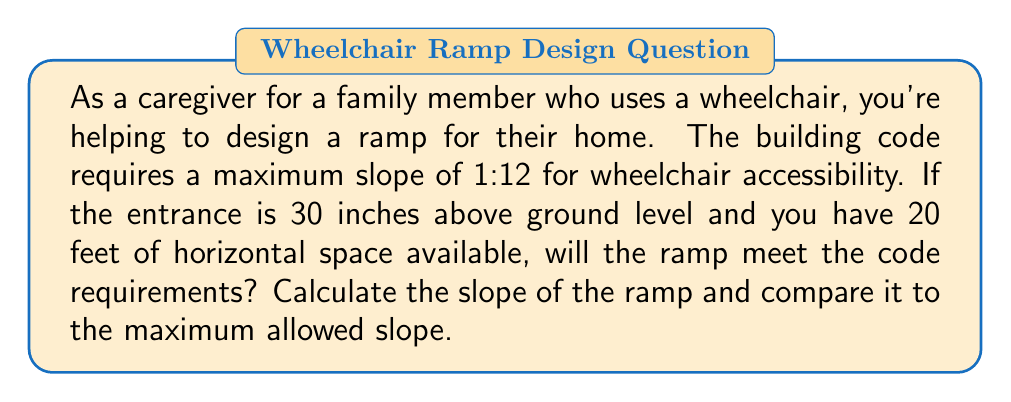Could you help me with this problem? Let's approach this step-by-step:

1) First, let's recall the formula for slope:

   $$ \text{Slope} = \frac{\text{Rise}}{\text{Run}} $$

2) In this case:
   - Rise = 30 inches (vertical distance)
   - Run = 20 feet = 240 inches (horizontal distance)

3) Calculate the slope:

   $$ \text{Slope} = \frac{30 \text{ inches}}{240 \text{ inches}} = \frac{1}{8} = 0.125 $$

4) To compare with the code requirement, let's convert 1:12 to a decimal:

   $$ \frac{1}{12} \approx 0.0833 $$

5) Compare the calculated slope to the maximum allowed slope:

   $0.125 > 0.0833$

6) The calculated slope (1:8) is steeper than the maximum allowed slope (1:12).

[asy]
unitsize(1cm);
pair A=(0,0), B=(12,0), C=(12,1);
draw(A--B--C--A);
label("1", (6,0.5), N);
label("12", (6,0), S);
draw((0,1.5)--(15,1.5), arrow=Arrow(TeXHead));
draw((0,1.5)--(0,-0.5), arrow=Arrow(TeXHead));
label("Run", (7.5,1.7), N);
label("Rise", (-0.2,0.5), W);
[/asy]
Answer: The slope of the ramp is $\frac{1}{8}$ or 0.125, which does not meet the code requirements. The ramp is too steep and needs to be redesigned with a longer run to achieve a slope of 1:12 or less. 